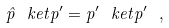<formula> <loc_0><loc_0><loc_500><loc_500>\hat { p } \ k e t { p ^ { \prime } } = p ^ { \prime } \ k e t { p ^ { \prime } } \ ,</formula> 